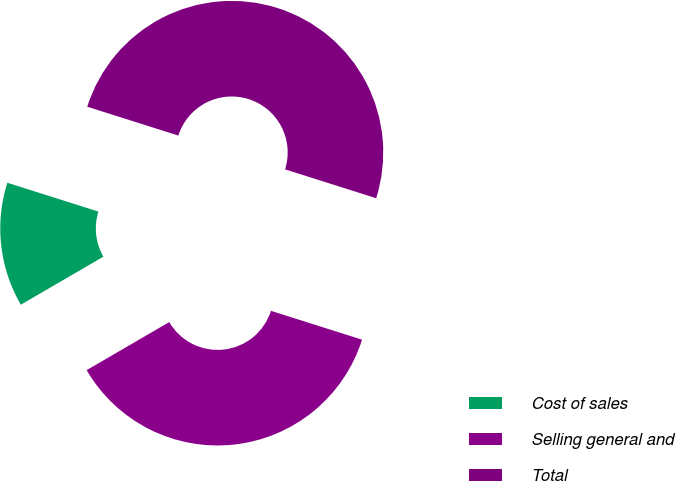<chart> <loc_0><loc_0><loc_500><loc_500><pie_chart><fcel>Cost of sales<fcel>Selling general and<fcel>Total<nl><fcel>13.27%<fcel>36.73%<fcel>50.0%<nl></chart> 